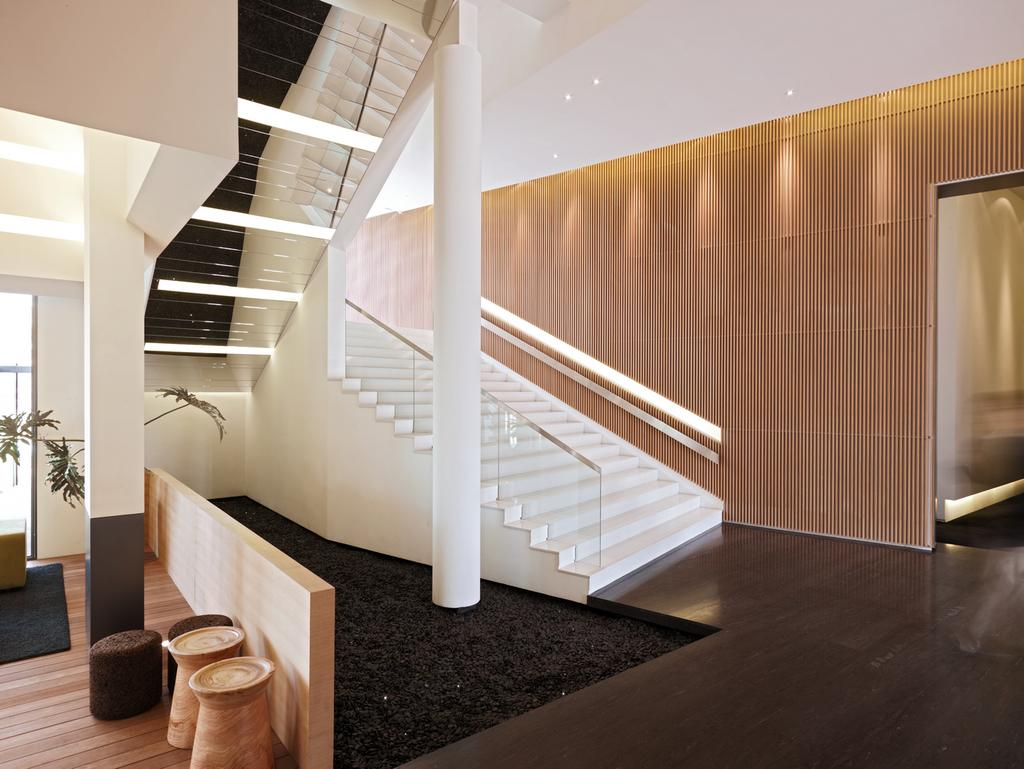What is on the floor in the image? There is a carpet on the floor in the image. What type of plant can be seen in the image? There is a house plant in the image. What architectural features are present in the image? There are pillars and steps in the image. What can be seen in the background of the image? There is a wall visible in the background of the image. What type of alarm can be heard going off in the image? There is no alarm present or audible in the image. Can you see anyone smashing the pillars in the image? There is no one smashing the pillars in the image; they are intact. 